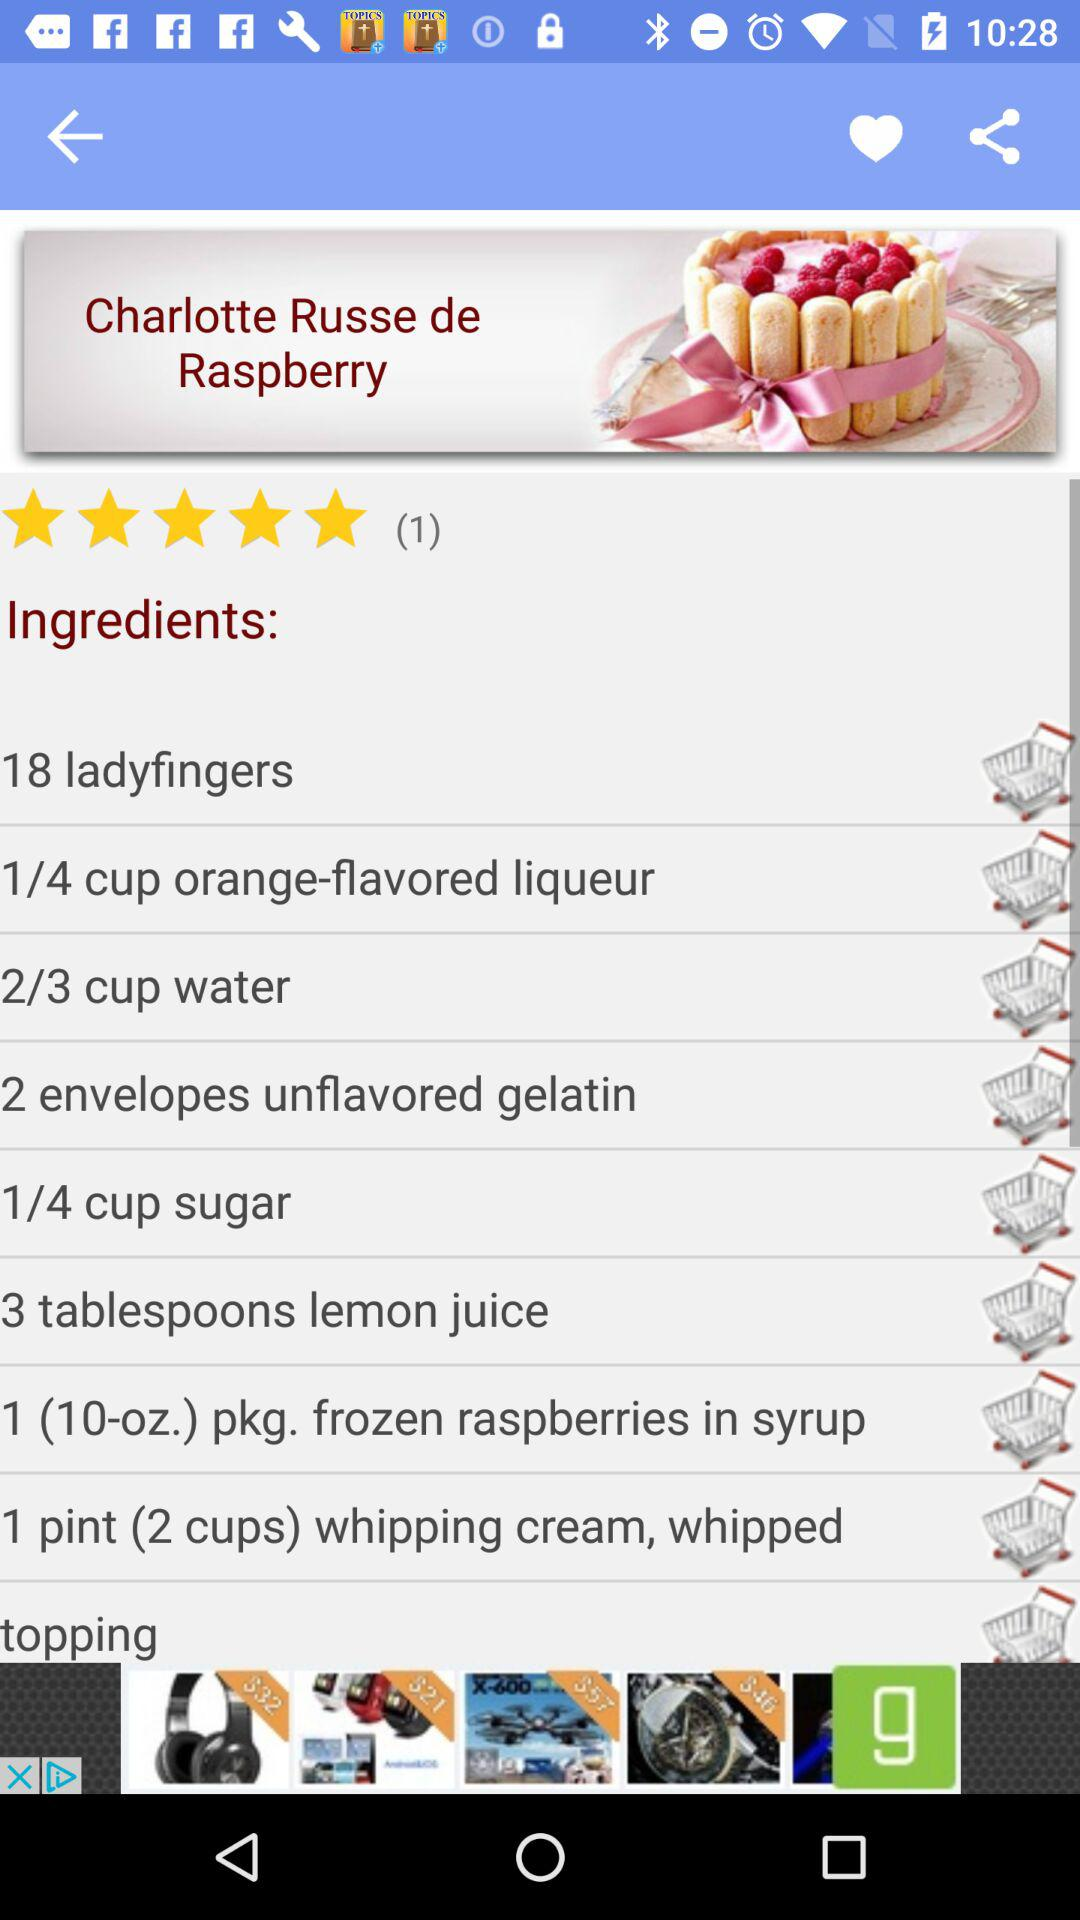How many users have rated "Charlotte Russe de Raspberry"? The number of users who have rated "Charlotte Russe de Raspberry" is 1. 